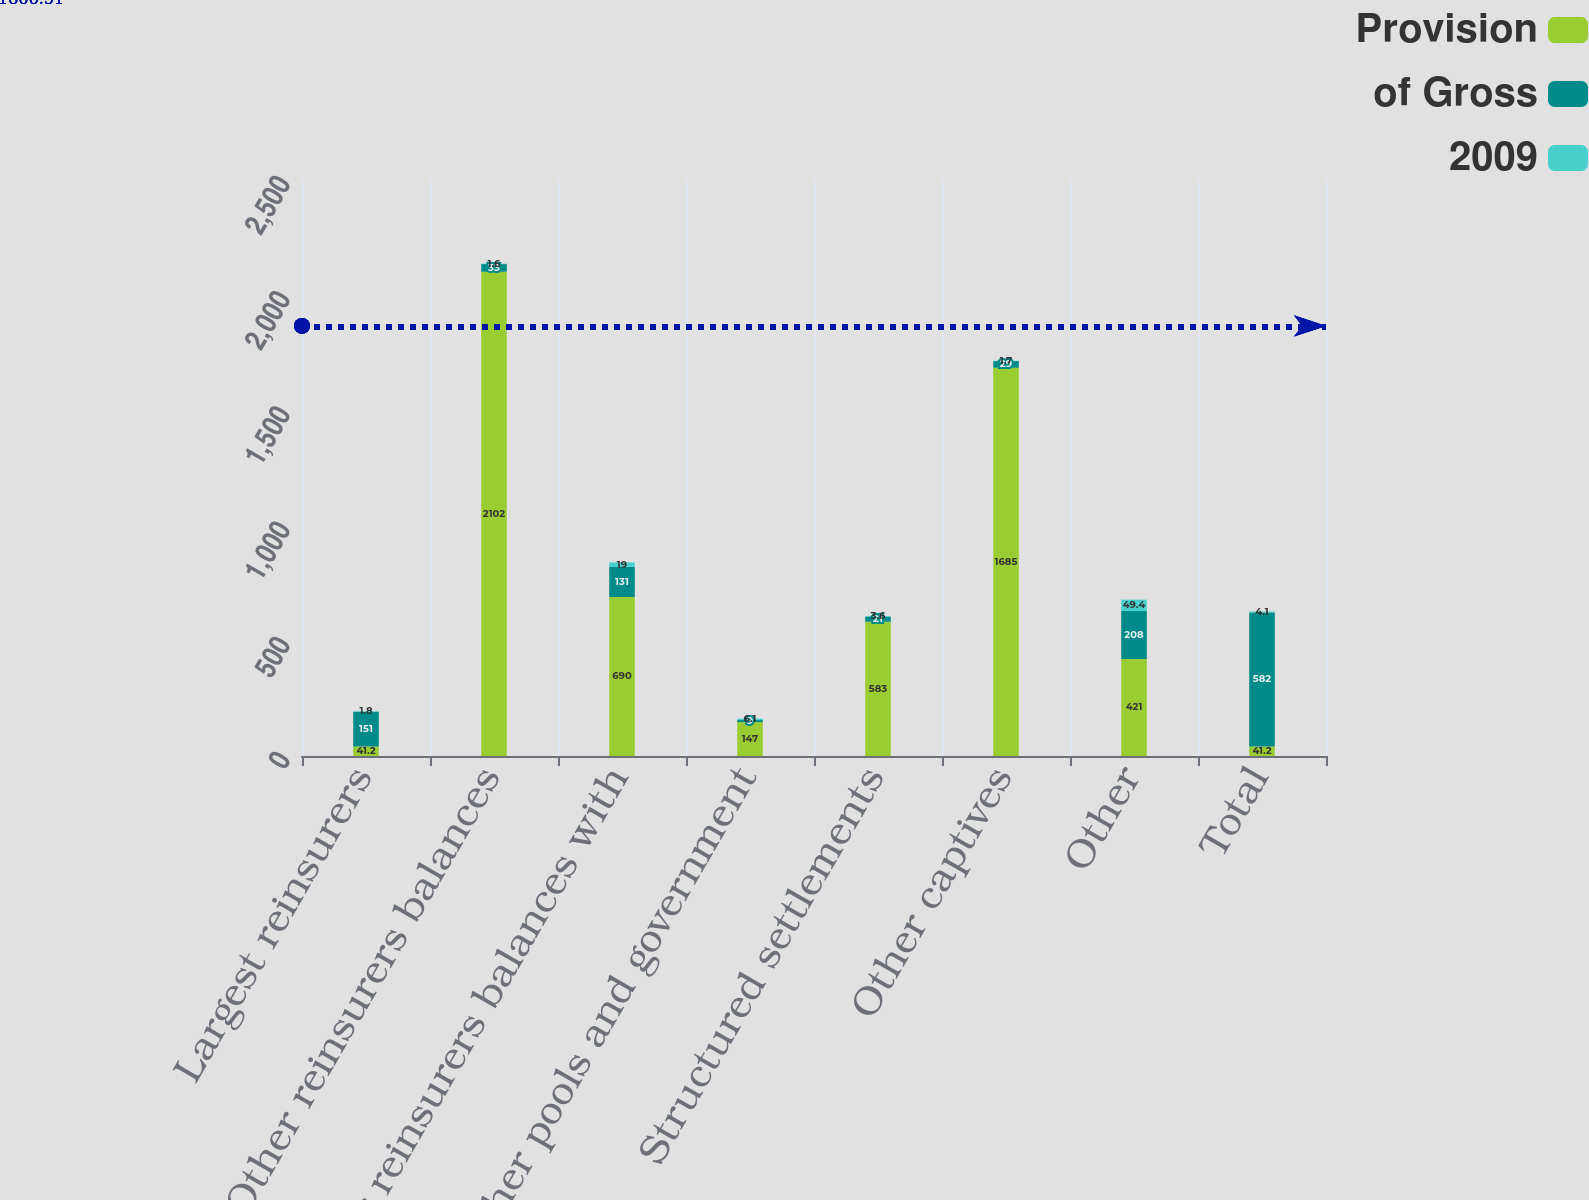Convert chart to OTSL. <chart><loc_0><loc_0><loc_500><loc_500><stacked_bar_chart><ecel><fcel>Largest reinsurers<fcel>Other reinsurers balances<fcel>Other reinsurers balances with<fcel>Other pools and government<fcel>Structured settlements<fcel>Other captives<fcel>Other<fcel>Total<nl><fcel>Provision<fcel>41.2<fcel>2102<fcel>690<fcel>147<fcel>583<fcel>1685<fcel>421<fcel>41.2<nl><fcel>of Gross<fcel>151<fcel>33<fcel>131<fcel>9<fcel>21<fcel>29<fcel>208<fcel>582<nl><fcel>2009<fcel>1.8<fcel>1.6<fcel>19<fcel>6.1<fcel>3.6<fcel>1.7<fcel>49.4<fcel>4.1<nl></chart> 